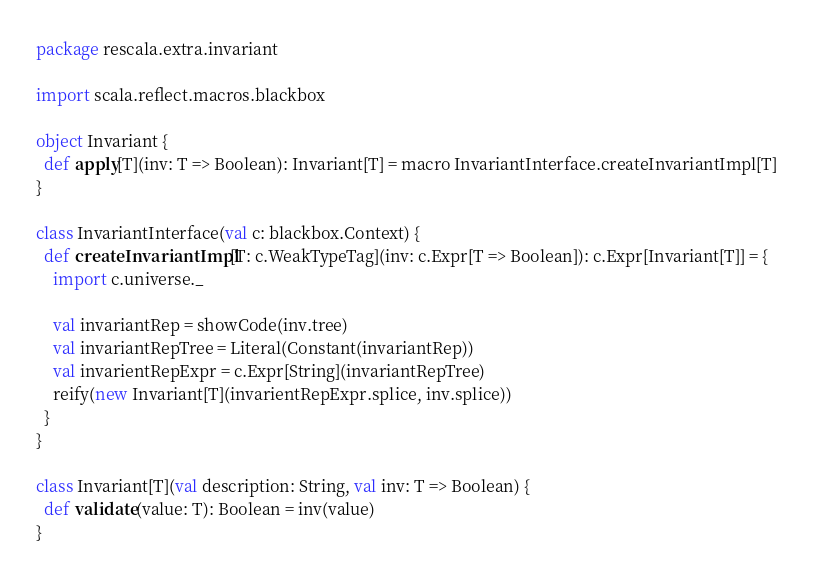<code> <loc_0><loc_0><loc_500><loc_500><_Scala_>package rescala.extra.invariant

import scala.reflect.macros.blackbox

object Invariant {
  def apply[T](inv: T => Boolean): Invariant[T] = macro InvariantInterface.createInvariantImpl[T]
}

class InvariantInterface(val c: blackbox.Context) {
  def createInvariantImpl[T: c.WeakTypeTag](inv: c.Expr[T => Boolean]): c.Expr[Invariant[T]] = {
    import c.universe._

    val invariantRep = showCode(inv.tree)
    val invariantRepTree = Literal(Constant(invariantRep))
    val invarientRepExpr = c.Expr[String](invariantRepTree)
    reify(new Invariant[T](invarientRepExpr.splice, inv.splice))
  }
}

class Invariant[T](val description: String, val inv: T => Boolean) {
  def validate(value: T): Boolean = inv(value)
}
</code> 